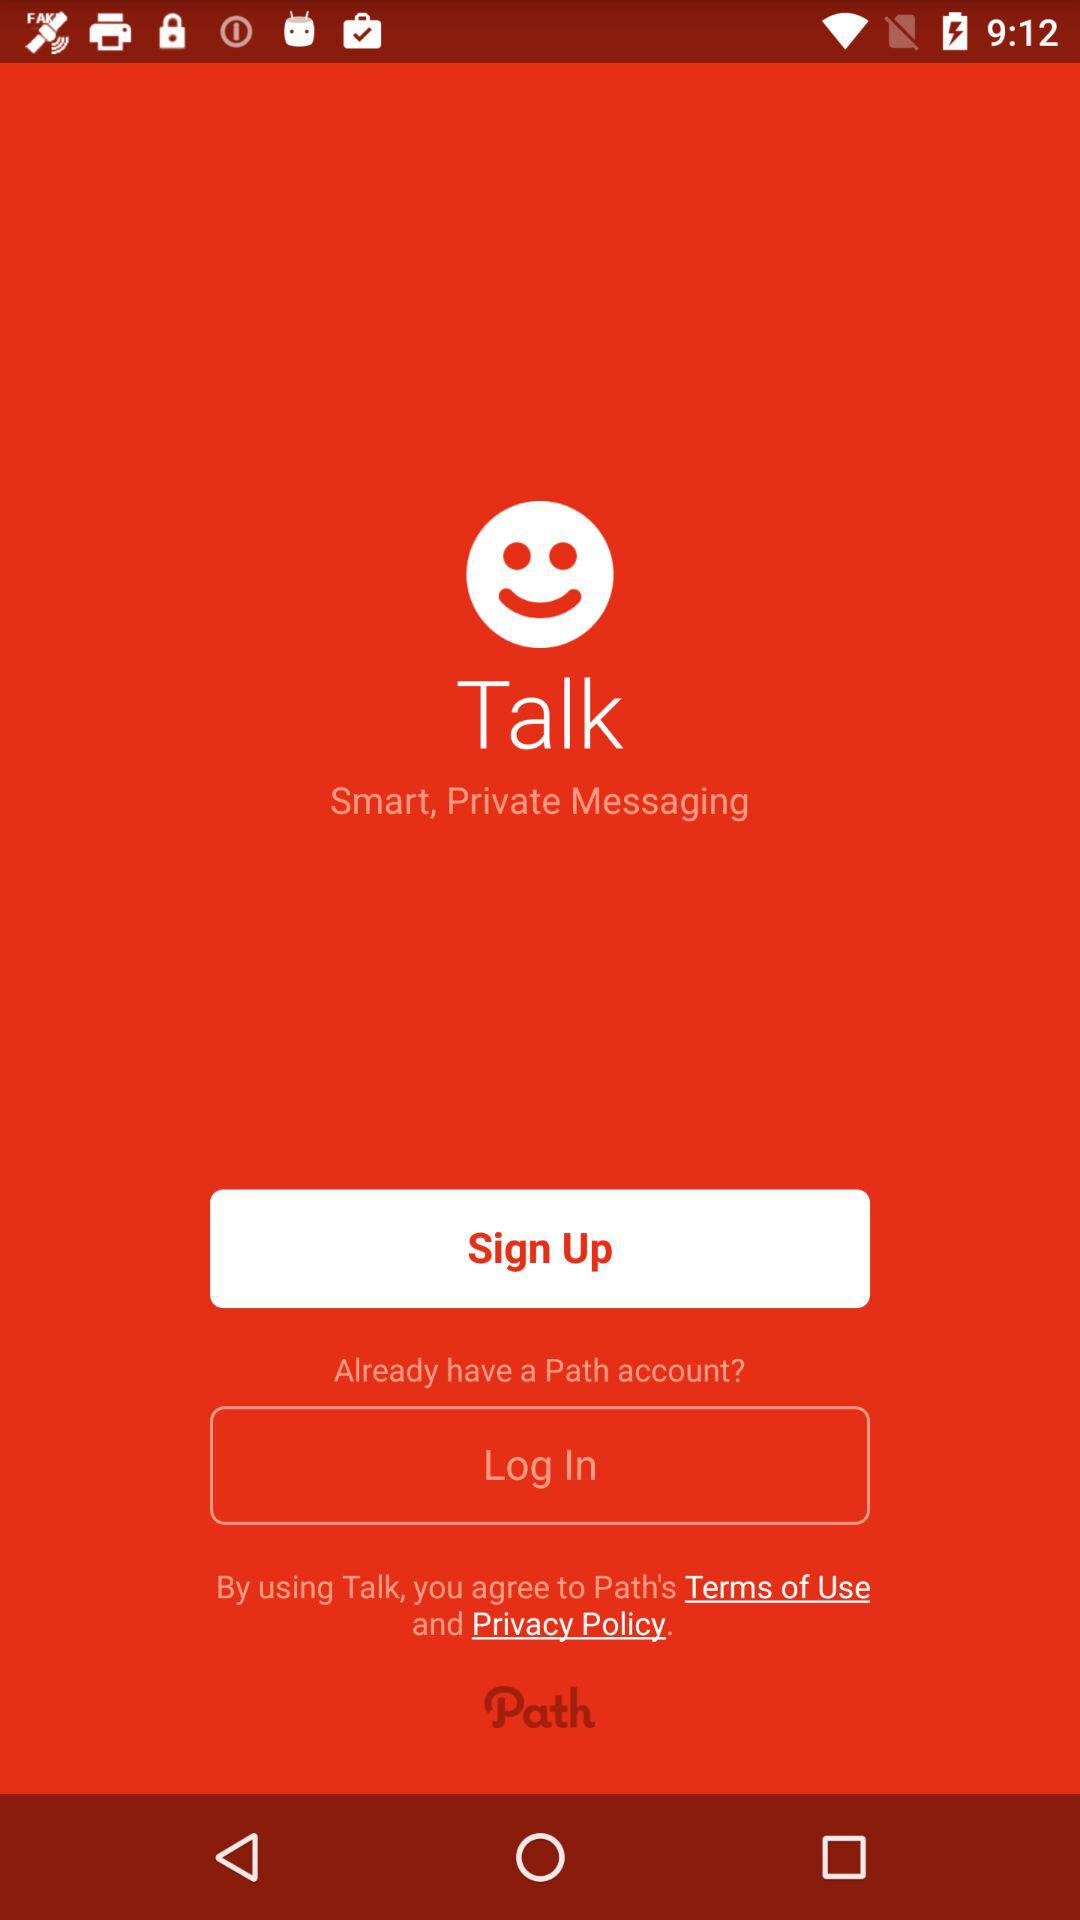What is the application name? The application name is "Talk". 